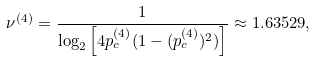<formula> <loc_0><loc_0><loc_500><loc_500>\nu ^ { ( 4 ) } = \frac { 1 } { \log _ { 2 } \left [ 4 p _ { c } ^ { ( 4 ) } ( 1 - ( p _ { c } ^ { ( 4 ) } ) ^ { 2 } ) \right ] } \approx 1 . 6 3 5 2 9 ,</formula> 